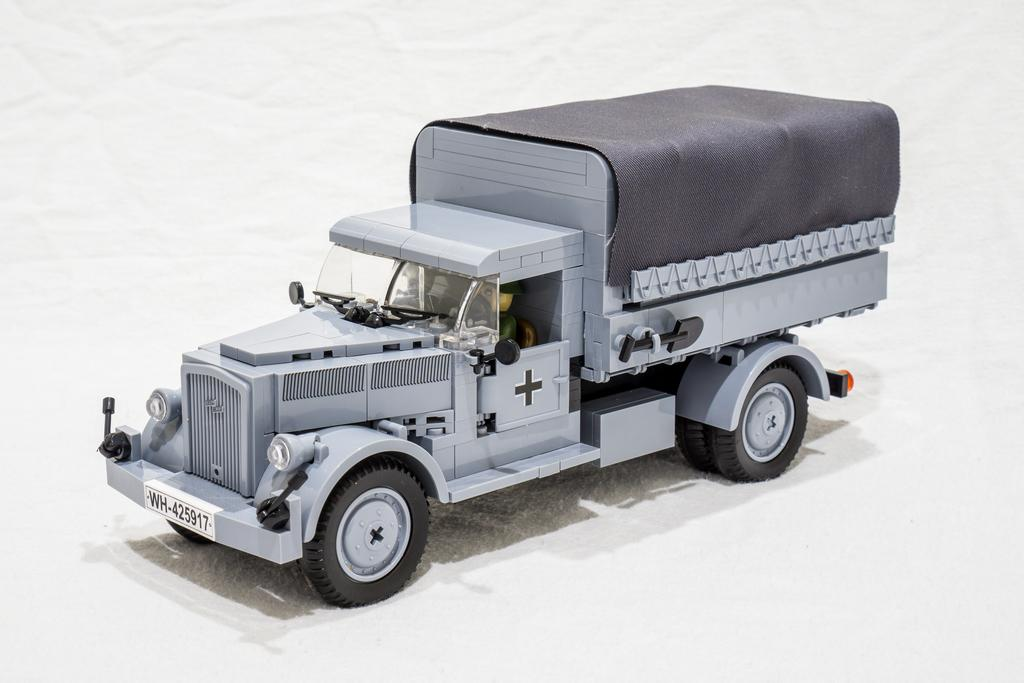What is the main subject of the image? There is a miniature truck in the image. Where is the truck located? The truck is on the ground. What is covering the ground in the image? The ground is covered with snow. What type of wood is the birthday dog made of in the image? There is no wood, birthday, or dog present in the image; it features a miniature truck on the snow-covered ground. 